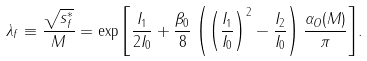<formula> <loc_0><loc_0><loc_500><loc_500>\lambda _ { f } \equiv \frac { \sqrt { s ^ { * } _ { f } } } { M } = \exp { \left [ \frac { I _ { 1 } } { 2 I _ { 0 } } + \frac { \beta _ { 0 } } { 8 } \left ( \left ( \frac { I _ { 1 } } { I _ { 0 } } \right ) ^ { 2 } - \frac { I _ { 2 } } { I _ { 0 } } \right ) \frac { \alpha _ { O } ( M ) } { \pi } \right ] } .</formula> 